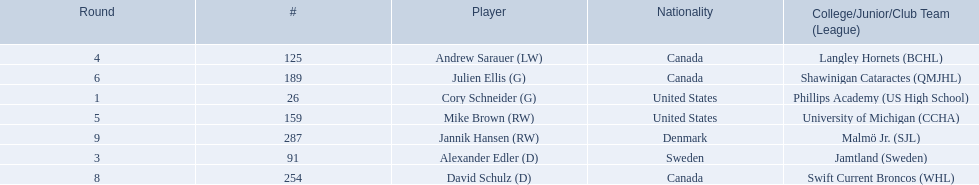Which players have canadian nationality? Andrew Sarauer (LW), Julien Ellis (G), David Schulz (D). Of those, which attended langley hornets? Andrew Sarauer (LW). 